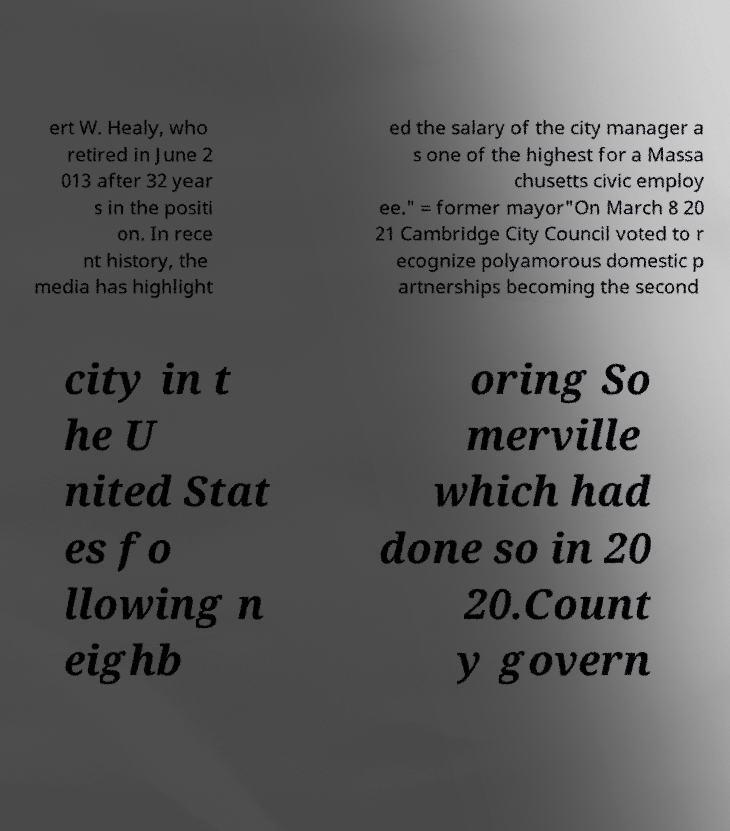Please identify and transcribe the text found in this image. ert W. Healy, who retired in June 2 013 after 32 year s in the positi on. In rece nt history, the media has highlight ed the salary of the city manager a s one of the highest for a Massa chusetts civic employ ee." = former mayor"On March 8 20 21 Cambridge City Council voted to r ecognize polyamorous domestic p artnerships becoming the second city in t he U nited Stat es fo llowing n eighb oring So merville which had done so in 20 20.Count y govern 